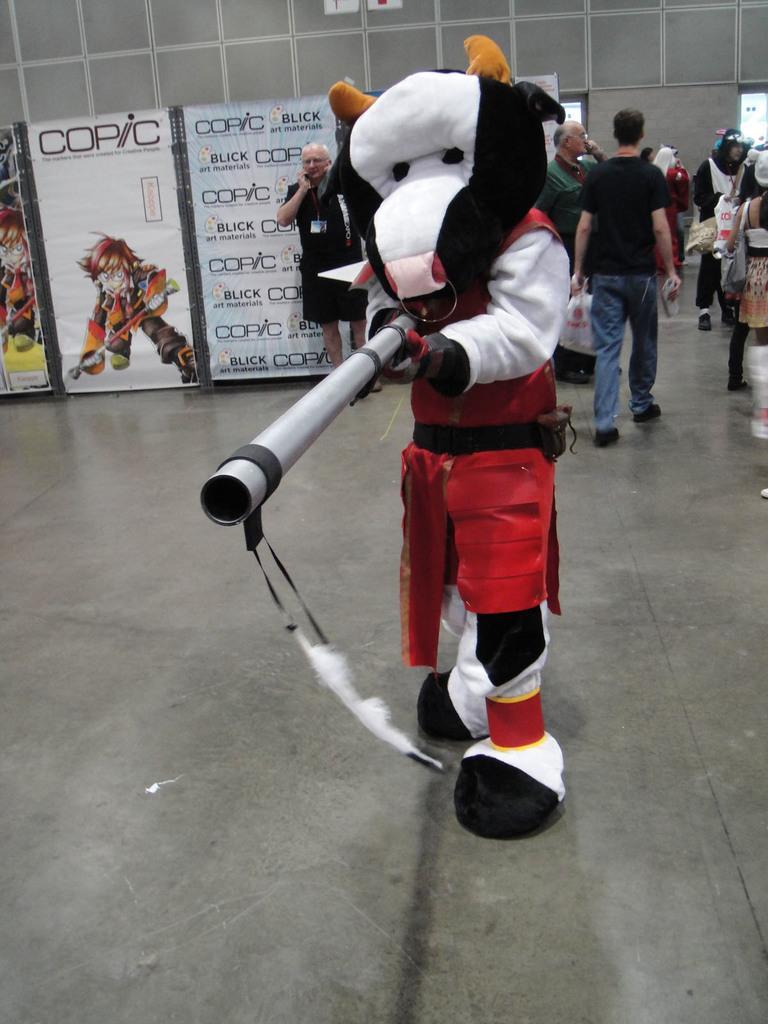How would you summarize this image in a sentence or two? In the middle of the picture, we see a person wearing mascot costume is holding something in his hand. Behind him, we see people are standing. Beside them, we see boards on which banner containing some text written is placed. On the right side, we see people are standing. In the background, we see a wall. 